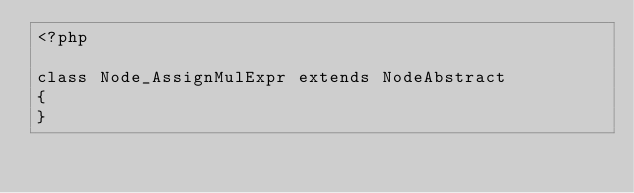<code> <loc_0><loc_0><loc_500><loc_500><_PHP_><?php

class Node_AssignMulExpr extends NodeAbstract
{
}</code> 